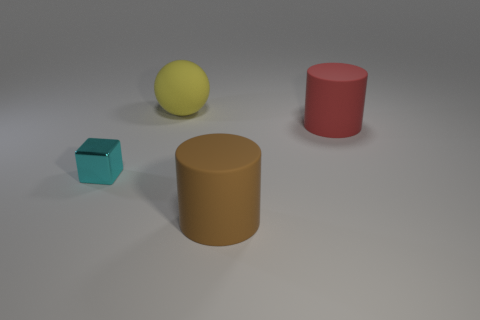Can you tell me the colors of the objects in this image? Of course! There are four objects, each with a distinct color. From left to right, there's a blue cube, a yellow ball, a red cylinder, and a brown cylinder. 